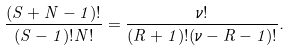<formula> <loc_0><loc_0><loc_500><loc_500>\frac { ( S + N - 1 ) ! } { ( S - 1 ) ! N ! } = \frac { \nu ! } { ( R + 1 ) ! ( \nu - R - 1 ) ! } .</formula> 